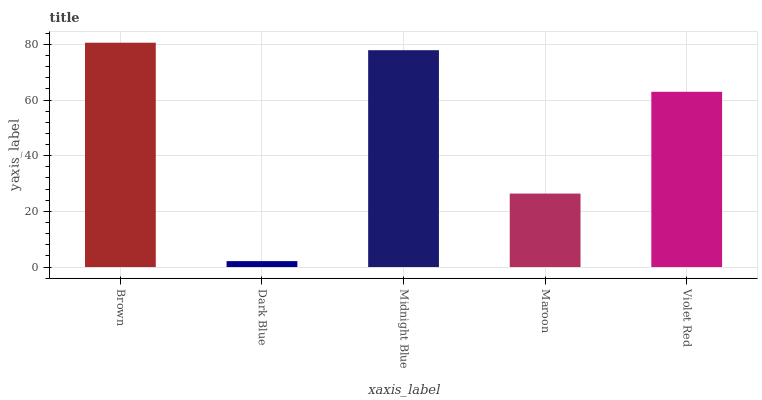Is Dark Blue the minimum?
Answer yes or no. Yes. Is Brown the maximum?
Answer yes or no. Yes. Is Midnight Blue the minimum?
Answer yes or no. No. Is Midnight Blue the maximum?
Answer yes or no. No. Is Midnight Blue greater than Dark Blue?
Answer yes or no. Yes. Is Dark Blue less than Midnight Blue?
Answer yes or no. Yes. Is Dark Blue greater than Midnight Blue?
Answer yes or no. No. Is Midnight Blue less than Dark Blue?
Answer yes or no. No. Is Violet Red the high median?
Answer yes or no. Yes. Is Violet Red the low median?
Answer yes or no. Yes. Is Midnight Blue the high median?
Answer yes or no. No. Is Midnight Blue the low median?
Answer yes or no. No. 